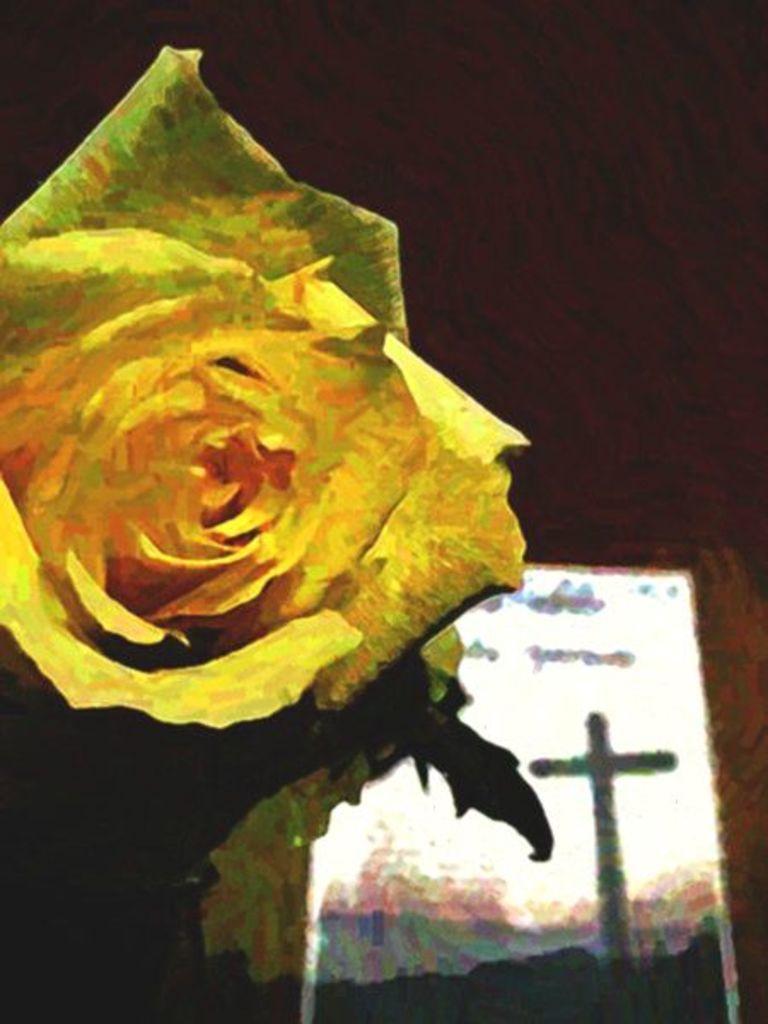Please provide a concise description of this image. In this image we can see the painting. In painting we can see a flower, a wall and an object in the image. 